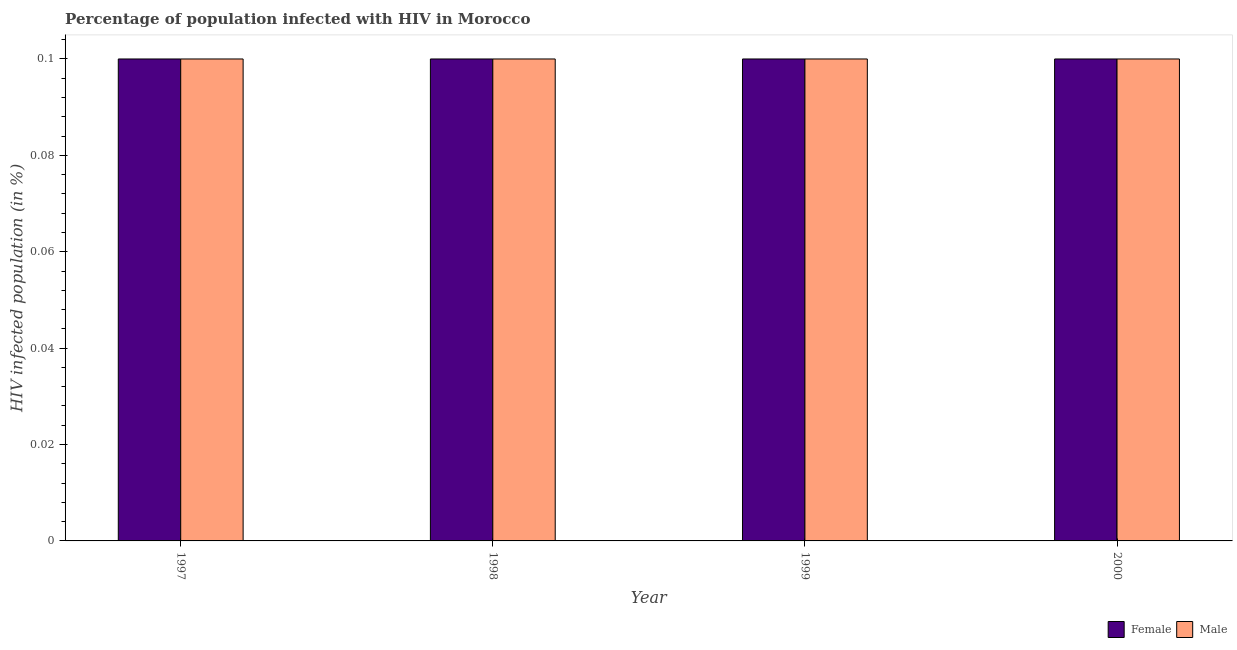How many groups of bars are there?
Keep it short and to the point. 4. Are the number of bars per tick equal to the number of legend labels?
Your response must be concise. Yes. Are the number of bars on each tick of the X-axis equal?
Your answer should be very brief. Yes. How many bars are there on the 2nd tick from the left?
Keep it short and to the point. 2. How many bars are there on the 4th tick from the right?
Your answer should be compact. 2. What is the label of the 3rd group of bars from the left?
Offer a terse response. 1999. What is the percentage of males who are infected with hiv in 1998?
Your answer should be compact. 0.1. Across all years, what is the maximum percentage of females who are infected with hiv?
Keep it short and to the point. 0.1. Across all years, what is the minimum percentage of males who are infected with hiv?
Your response must be concise. 0.1. In which year was the percentage of females who are infected with hiv minimum?
Keep it short and to the point. 1997. What is the total percentage of males who are infected with hiv in the graph?
Keep it short and to the point. 0.4. What is the difference between the percentage of females who are infected with hiv in 1997 and that in 1999?
Ensure brevity in your answer.  0. In how many years, is the percentage of females who are infected with hiv greater than 0.02 %?
Provide a succinct answer. 4. Is the percentage of females who are infected with hiv in 1997 less than that in 1998?
Offer a terse response. No. In how many years, is the percentage of females who are infected with hiv greater than the average percentage of females who are infected with hiv taken over all years?
Provide a short and direct response. 0. Is the sum of the percentage of females who are infected with hiv in 1998 and 1999 greater than the maximum percentage of males who are infected with hiv across all years?
Make the answer very short. Yes. What does the 2nd bar from the left in 1999 represents?
Make the answer very short. Male. Are the values on the major ticks of Y-axis written in scientific E-notation?
Provide a short and direct response. No. Does the graph contain grids?
Give a very brief answer. No. How many legend labels are there?
Make the answer very short. 2. What is the title of the graph?
Ensure brevity in your answer.  Percentage of population infected with HIV in Morocco. What is the label or title of the X-axis?
Your answer should be compact. Year. What is the label or title of the Y-axis?
Make the answer very short. HIV infected population (in %). What is the HIV infected population (in %) in Female in 1998?
Offer a very short reply. 0.1. What is the HIV infected population (in %) in Male in 1998?
Your response must be concise. 0.1. What is the HIV infected population (in %) of Female in 2000?
Ensure brevity in your answer.  0.1. Across all years, what is the maximum HIV infected population (in %) of Female?
Your response must be concise. 0.1. Across all years, what is the maximum HIV infected population (in %) of Male?
Make the answer very short. 0.1. Across all years, what is the minimum HIV infected population (in %) in Female?
Keep it short and to the point. 0.1. What is the total HIV infected population (in %) of Male in the graph?
Your answer should be very brief. 0.4. What is the difference between the HIV infected population (in %) of Female in 1997 and that in 1999?
Your answer should be very brief. 0. What is the difference between the HIV infected population (in %) of Male in 1998 and that in 2000?
Provide a succinct answer. 0. What is the difference between the HIV infected population (in %) of Female in 1999 and that in 2000?
Keep it short and to the point. 0. What is the difference between the HIV infected population (in %) in Female in 1997 and the HIV infected population (in %) in Male in 2000?
Provide a short and direct response. 0. What is the difference between the HIV infected population (in %) of Female in 1998 and the HIV infected population (in %) of Male in 2000?
Your response must be concise. 0. What is the difference between the HIV infected population (in %) in Female in 1999 and the HIV infected population (in %) in Male in 2000?
Offer a terse response. 0. What is the average HIV infected population (in %) in Female per year?
Give a very brief answer. 0.1. What is the average HIV infected population (in %) of Male per year?
Provide a succinct answer. 0.1. In the year 1997, what is the difference between the HIV infected population (in %) of Female and HIV infected population (in %) of Male?
Your answer should be very brief. 0. In the year 1998, what is the difference between the HIV infected population (in %) of Female and HIV infected population (in %) of Male?
Keep it short and to the point. 0. In the year 2000, what is the difference between the HIV infected population (in %) of Female and HIV infected population (in %) of Male?
Offer a very short reply. 0. What is the ratio of the HIV infected population (in %) in Female in 1997 to that in 1998?
Keep it short and to the point. 1. What is the ratio of the HIV infected population (in %) in Female in 1997 to that in 2000?
Your response must be concise. 1. What is the ratio of the HIV infected population (in %) in Male in 1997 to that in 2000?
Keep it short and to the point. 1. What is the ratio of the HIV infected population (in %) of Female in 1998 to that in 1999?
Provide a succinct answer. 1. What is the ratio of the HIV infected population (in %) of Female in 1998 to that in 2000?
Your response must be concise. 1. What is the ratio of the HIV infected population (in %) of Male in 1998 to that in 2000?
Offer a very short reply. 1. What is the ratio of the HIV infected population (in %) in Female in 1999 to that in 2000?
Give a very brief answer. 1. What is the ratio of the HIV infected population (in %) of Male in 1999 to that in 2000?
Provide a short and direct response. 1. What is the difference between the highest and the second highest HIV infected population (in %) of Female?
Give a very brief answer. 0. What is the difference between the highest and the second highest HIV infected population (in %) of Male?
Make the answer very short. 0. What is the difference between the highest and the lowest HIV infected population (in %) in Male?
Offer a terse response. 0. 